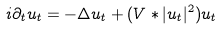Convert formula to latex. <formula><loc_0><loc_0><loc_500><loc_500>i \partial _ { t } u _ { t } = - \Delta u _ { t } + ( V * | u _ { t } | ^ { 2 } ) u _ { t }</formula> 